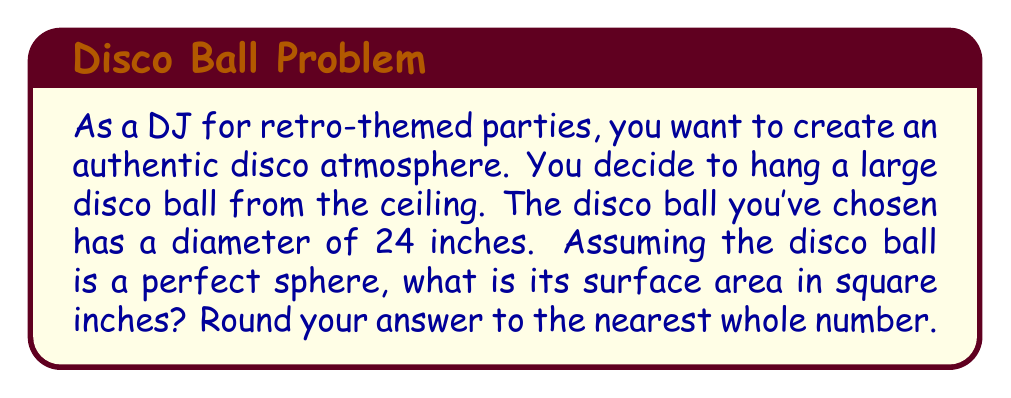What is the answer to this math problem? To solve this problem, we need to follow these steps:

1. Recall the formula for the surface area of a sphere:
   $$A = 4\pi r^2$$
   where $A$ is the surface area and $r$ is the radius of the sphere.

2. We're given the diameter, so we need to calculate the radius:
   $$r = \frac{diameter}{2} = \frac{24}{2} = 12\text{ inches}$$

3. Now, let's substitute this into our surface area formula:
   $$A = 4\pi (12)^2$$

4. Simplify:
   $$A = 4\pi (144) = 576\pi\text{ square inches}$$

5. Calculate the result:
   $$A \approx 1809.56\text{ square inches}$$

6. Rounding to the nearest whole number:
   $$A \approx 1810\text{ square inches}$$

[asy]
import geometry;

size(100);
draw(circle((0,0),1), blue);
draw((-1,0)--(1,0), dashed);
label("24\"", (0,-1.2), S);
label("r = 12\"", (0.5,0), NE);
[/asy]
Answer: The surface area of the disco ball is approximately 1810 square inches. 